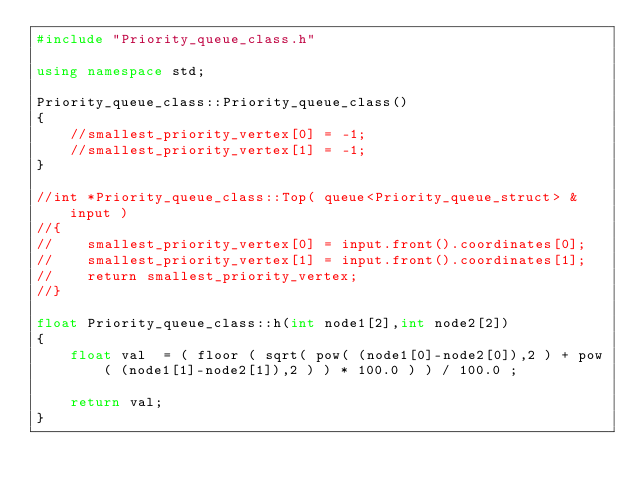<code> <loc_0><loc_0><loc_500><loc_500><_C++_>#include "Priority_queue_class.h"

using namespace std;

Priority_queue_class::Priority_queue_class()
{
    //smallest_priority_vertex[0] = -1;
    //smallest_priority_vertex[1] = -1;
}

//int *Priority_queue_class::Top( queue<Priority_queue_struct> &input )
//{
//    smallest_priority_vertex[0] = input.front().coordinates[0];
//    smallest_priority_vertex[1] = input.front().coordinates[1];
//    return smallest_priority_vertex;
//}

float Priority_queue_class::h(int node1[2],int node2[2])
{
    float val  = ( floor ( sqrt( pow( (node1[0]-node2[0]),2 ) + pow( (node1[1]-node2[1]),2 ) ) * 100.0 ) ) / 100.0 ;

    return val;
}
</code> 